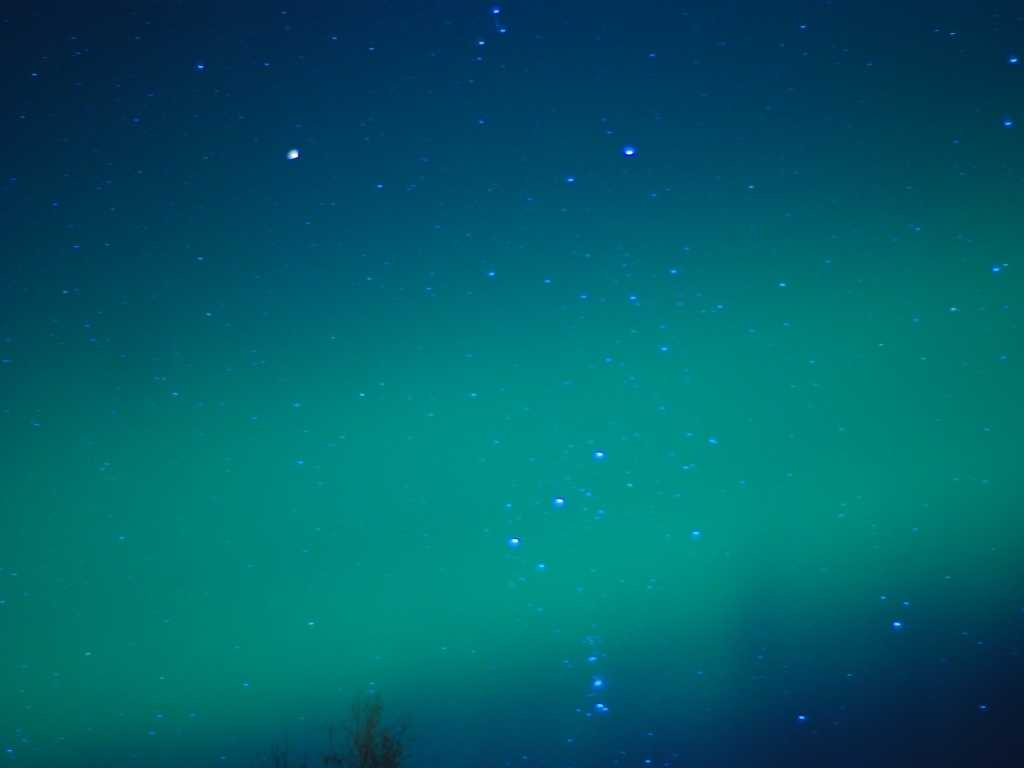Can you tell me what the green color in the image represents? Certainly, the dazzling green hue typically corresponds to oxygen molecules about 60 miles above the Earth, being excited by solar particles colliding with the Earth's atmosphere, a process that generates this mesmerizing glow. How often can we see such occurrences? The frequency of the Aurora Borealis largely depends on solar activity, but it's more commonly observed during the equinoxes in March and September. Geographic location is also crucial, with higher latitude areas such as Scandinavia, Canada, and Alaska offering more regular displays. 